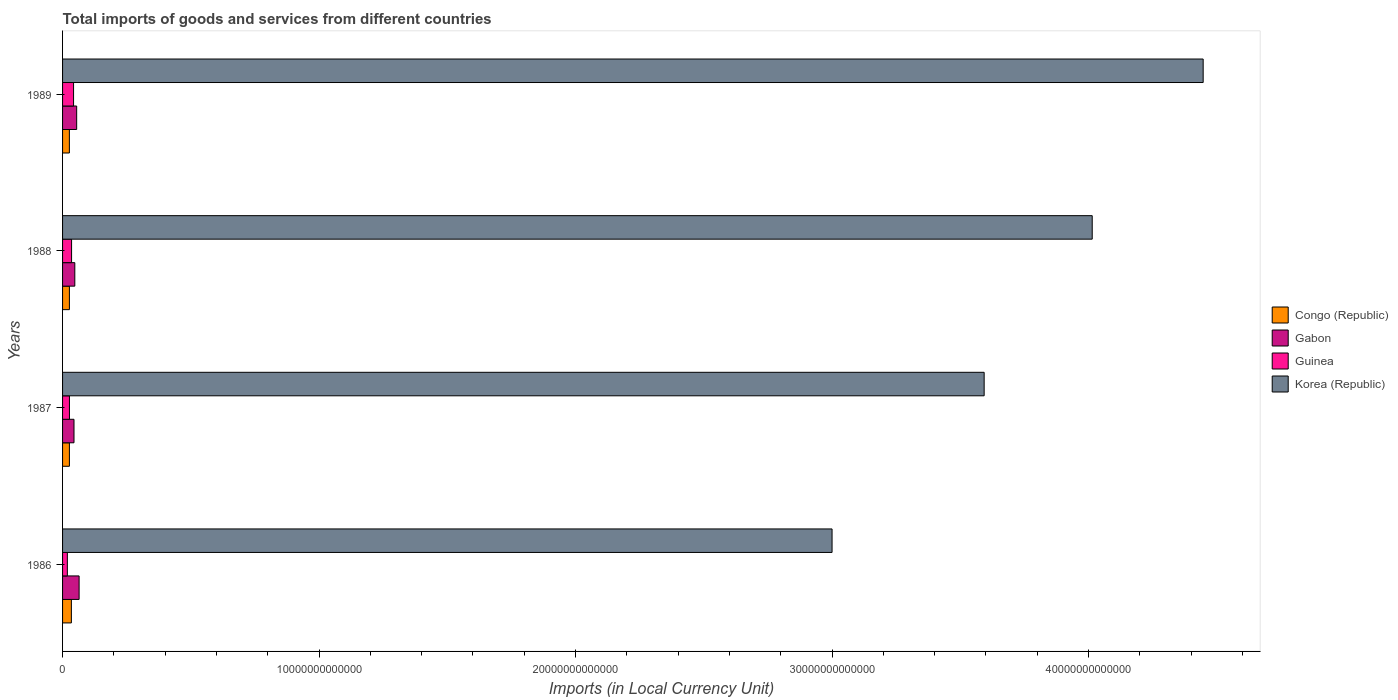How many groups of bars are there?
Ensure brevity in your answer.  4. Are the number of bars per tick equal to the number of legend labels?
Your answer should be very brief. Yes. Are the number of bars on each tick of the Y-axis equal?
Ensure brevity in your answer.  Yes. How many bars are there on the 1st tick from the top?
Provide a short and direct response. 4. How many bars are there on the 2nd tick from the bottom?
Offer a very short reply. 4. In how many cases, is the number of bars for a given year not equal to the number of legend labels?
Give a very brief answer. 0. What is the Amount of goods and services imports in Korea (Republic) in 1986?
Give a very brief answer. 3.00e+13. Across all years, what is the maximum Amount of goods and services imports in Guinea?
Your response must be concise. 4.29e+11. Across all years, what is the minimum Amount of goods and services imports in Korea (Republic)?
Make the answer very short. 3.00e+13. In which year was the Amount of goods and services imports in Korea (Republic) minimum?
Your response must be concise. 1986. What is the total Amount of goods and services imports in Korea (Republic) in the graph?
Offer a very short reply. 1.51e+14. What is the difference between the Amount of goods and services imports in Congo (Republic) in 1986 and that in 1988?
Give a very brief answer. 7.73e+1. What is the difference between the Amount of goods and services imports in Congo (Republic) in 1987 and the Amount of goods and services imports in Gabon in 1986?
Offer a terse response. -3.78e+11. What is the average Amount of goods and services imports in Korea (Republic) per year?
Your answer should be compact. 3.76e+13. In the year 1988, what is the difference between the Amount of goods and services imports in Korea (Republic) and Amount of goods and services imports in Gabon?
Your response must be concise. 3.97e+13. What is the ratio of the Amount of goods and services imports in Korea (Republic) in 1987 to that in 1988?
Give a very brief answer. 0.9. Is the Amount of goods and services imports in Congo (Republic) in 1987 less than that in 1988?
Offer a very short reply. No. Is the difference between the Amount of goods and services imports in Korea (Republic) in 1986 and 1988 greater than the difference between the Amount of goods and services imports in Gabon in 1986 and 1988?
Provide a succinct answer. No. What is the difference between the highest and the second highest Amount of goods and services imports in Korea (Republic)?
Provide a short and direct response. 4.33e+12. What is the difference between the highest and the lowest Amount of goods and services imports in Gabon?
Your response must be concise. 1.99e+11. What does the 2nd bar from the bottom in 1986 represents?
Give a very brief answer. Gabon. Is it the case that in every year, the sum of the Amount of goods and services imports in Korea (Republic) and Amount of goods and services imports in Guinea is greater than the Amount of goods and services imports in Congo (Republic)?
Offer a very short reply. Yes. How many bars are there?
Your answer should be compact. 16. How many years are there in the graph?
Keep it short and to the point. 4. What is the difference between two consecutive major ticks on the X-axis?
Keep it short and to the point. 1.00e+13. Are the values on the major ticks of X-axis written in scientific E-notation?
Your answer should be compact. No. Does the graph contain grids?
Your response must be concise. No. Where does the legend appear in the graph?
Provide a short and direct response. Center right. What is the title of the graph?
Your response must be concise. Total imports of goods and services from different countries. What is the label or title of the X-axis?
Give a very brief answer. Imports (in Local Currency Unit). What is the Imports (in Local Currency Unit) in Congo (Republic) in 1986?
Provide a succinct answer. 3.44e+11. What is the Imports (in Local Currency Unit) of Gabon in 1986?
Provide a succinct answer. 6.45e+11. What is the Imports (in Local Currency Unit) of Guinea in 1986?
Offer a terse response. 1.87e+11. What is the Imports (in Local Currency Unit) of Korea (Republic) in 1986?
Your response must be concise. 3.00e+13. What is the Imports (in Local Currency Unit) in Congo (Republic) in 1987?
Give a very brief answer. 2.67e+11. What is the Imports (in Local Currency Unit) of Gabon in 1987?
Your answer should be compact. 4.46e+11. What is the Imports (in Local Currency Unit) in Guinea in 1987?
Your response must be concise. 2.69e+11. What is the Imports (in Local Currency Unit) of Korea (Republic) in 1987?
Offer a terse response. 3.59e+13. What is the Imports (in Local Currency Unit) of Congo (Republic) in 1988?
Provide a succinct answer. 2.66e+11. What is the Imports (in Local Currency Unit) in Gabon in 1988?
Your response must be concise. 4.77e+11. What is the Imports (in Local Currency Unit) of Guinea in 1988?
Offer a very short reply. 3.51e+11. What is the Imports (in Local Currency Unit) in Korea (Republic) in 1988?
Ensure brevity in your answer.  4.01e+13. What is the Imports (in Local Currency Unit) of Congo (Republic) in 1989?
Give a very brief answer. 2.66e+11. What is the Imports (in Local Currency Unit) in Gabon in 1989?
Offer a terse response. 5.50e+11. What is the Imports (in Local Currency Unit) in Guinea in 1989?
Give a very brief answer. 4.29e+11. What is the Imports (in Local Currency Unit) of Korea (Republic) in 1989?
Offer a terse response. 4.45e+13. Across all years, what is the maximum Imports (in Local Currency Unit) of Congo (Republic)?
Provide a short and direct response. 3.44e+11. Across all years, what is the maximum Imports (in Local Currency Unit) of Gabon?
Your answer should be very brief. 6.45e+11. Across all years, what is the maximum Imports (in Local Currency Unit) of Guinea?
Make the answer very short. 4.29e+11. Across all years, what is the maximum Imports (in Local Currency Unit) in Korea (Republic)?
Ensure brevity in your answer.  4.45e+13. Across all years, what is the minimum Imports (in Local Currency Unit) in Congo (Republic)?
Ensure brevity in your answer.  2.66e+11. Across all years, what is the minimum Imports (in Local Currency Unit) of Gabon?
Offer a terse response. 4.46e+11. Across all years, what is the minimum Imports (in Local Currency Unit) in Guinea?
Ensure brevity in your answer.  1.87e+11. Across all years, what is the minimum Imports (in Local Currency Unit) of Korea (Republic)?
Ensure brevity in your answer.  3.00e+13. What is the total Imports (in Local Currency Unit) in Congo (Republic) in the graph?
Keep it short and to the point. 1.14e+12. What is the total Imports (in Local Currency Unit) of Gabon in the graph?
Make the answer very short. 2.12e+12. What is the total Imports (in Local Currency Unit) in Guinea in the graph?
Keep it short and to the point. 1.24e+12. What is the total Imports (in Local Currency Unit) of Korea (Republic) in the graph?
Offer a very short reply. 1.51e+14. What is the difference between the Imports (in Local Currency Unit) in Congo (Republic) in 1986 and that in 1987?
Give a very brief answer. 7.70e+1. What is the difference between the Imports (in Local Currency Unit) in Gabon in 1986 and that in 1987?
Make the answer very short. 1.99e+11. What is the difference between the Imports (in Local Currency Unit) of Guinea in 1986 and that in 1987?
Give a very brief answer. -8.18e+1. What is the difference between the Imports (in Local Currency Unit) of Korea (Republic) in 1986 and that in 1987?
Make the answer very short. -5.93e+12. What is the difference between the Imports (in Local Currency Unit) in Congo (Republic) in 1986 and that in 1988?
Offer a very short reply. 7.73e+1. What is the difference between the Imports (in Local Currency Unit) of Gabon in 1986 and that in 1988?
Your response must be concise. 1.68e+11. What is the difference between the Imports (in Local Currency Unit) of Guinea in 1986 and that in 1988?
Provide a succinct answer. -1.65e+11. What is the difference between the Imports (in Local Currency Unit) in Korea (Republic) in 1986 and that in 1988?
Keep it short and to the point. -1.01e+13. What is the difference between the Imports (in Local Currency Unit) of Congo (Republic) in 1986 and that in 1989?
Offer a terse response. 7.82e+1. What is the difference between the Imports (in Local Currency Unit) of Gabon in 1986 and that in 1989?
Keep it short and to the point. 9.46e+1. What is the difference between the Imports (in Local Currency Unit) in Guinea in 1986 and that in 1989?
Offer a terse response. -2.42e+11. What is the difference between the Imports (in Local Currency Unit) of Korea (Republic) in 1986 and that in 1989?
Offer a very short reply. -1.45e+13. What is the difference between the Imports (in Local Currency Unit) of Congo (Republic) in 1987 and that in 1988?
Your answer should be very brief. 3.00e+08. What is the difference between the Imports (in Local Currency Unit) in Gabon in 1987 and that in 1988?
Provide a short and direct response. -3.13e+1. What is the difference between the Imports (in Local Currency Unit) in Guinea in 1987 and that in 1988?
Offer a very short reply. -8.29e+1. What is the difference between the Imports (in Local Currency Unit) in Korea (Republic) in 1987 and that in 1988?
Give a very brief answer. -4.21e+12. What is the difference between the Imports (in Local Currency Unit) in Congo (Republic) in 1987 and that in 1989?
Your answer should be very brief. 1.20e+09. What is the difference between the Imports (in Local Currency Unit) of Gabon in 1987 and that in 1989?
Give a very brief answer. -1.04e+11. What is the difference between the Imports (in Local Currency Unit) in Guinea in 1987 and that in 1989?
Your answer should be compact. -1.60e+11. What is the difference between the Imports (in Local Currency Unit) in Korea (Republic) in 1987 and that in 1989?
Keep it short and to the point. -8.54e+12. What is the difference between the Imports (in Local Currency Unit) of Congo (Republic) in 1988 and that in 1989?
Give a very brief answer. 9.00e+08. What is the difference between the Imports (in Local Currency Unit) in Gabon in 1988 and that in 1989?
Your response must be concise. -7.29e+1. What is the difference between the Imports (in Local Currency Unit) in Guinea in 1988 and that in 1989?
Your answer should be compact. -7.71e+1. What is the difference between the Imports (in Local Currency Unit) in Korea (Republic) in 1988 and that in 1989?
Your answer should be very brief. -4.33e+12. What is the difference between the Imports (in Local Currency Unit) in Congo (Republic) in 1986 and the Imports (in Local Currency Unit) in Gabon in 1987?
Give a very brief answer. -1.02e+11. What is the difference between the Imports (in Local Currency Unit) in Congo (Republic) in 1986 and the Imports (in Local Currency Unit) in Guinea in 1987?
Provide a short and direct response. 7.52e+1. What is the difference between the Imports (in Local Currency Unit) of Congo (Republic) in 1986 and the Imports (in Local Currency Unit) of Korea (Republic) in 1987?
Provide a succinct answer. -3.56e+13. What is the difference between the Imports (in Local Currency Unit) of Gabon in 1986 and the Imports (in Local Currency Unit) of Guinea in 1987?
Make the answer very short. 3.76e+11. What is the difference between the Imports (in Local Currency Unit) in Gabon in 1986 and the Imports (in Local Currency Unit) in Korea (Republic) in 1987?
Your answer should be compact. -3.53e+13. What is the difference between the Imports (in Local Currency Unit) in Guinea in 1986 and the Imports (in Local Currency Unit) in Korea (Republic) in 1987?
Ensure brevity in your answer.  -3.57e+13. What is the difference between the Imports (in Local Currency Unit) in Congo (Republic) in 1986 and the Imports (in Local Currency Unit) in Gabon in 1988?
Keep it short and to the point. -1.34e+11. What is the difference between the Imports (in Local Currency Unit) of Congo (Republic) in 1986 and the Imports (in Local Currency Unit) of Guinea in 1988?
Provide a short and direct response. -7.78e+09. What is the difference between the Imports (in Local Currency Unit) of Congo (Republic) in 1986 and the Imports (in Local Currency Unit) of Korea (Republic) in 1988?
Provide a succinct answer. -3.98e+13. What is the difference between the Imports (in Local Currency Unit) of Gabon in 1986 and the Imports (in Local Currency Unit) of Guinea in 1988?
Your answer should be very brief. 2.93e+11. What is the difference between the Imports (in Local Currency Unit) in Gabon in 1986 and the Imports (in Local Currency Unit) in Korea (Republic) in 1988?
Your answer should be very brief. -3.95e+13. What is the difference between the Imports (in Local Currency Unit) of Guinea in 1986 and the Imports (in Local Currency Unit) of Korea (Republic) in 1988?
Make the answer very short. -4.00e+13. What is the difference between the Imports (in Local Currency Unit) in Congo (Republic) in 1986 and the Imports (in Local Currency Unit) in Gabon in 1989?
Offer a very short reply. -2.06e+11. What is the difference between the Imports (in Local Currency Unit) in Congo (Republic) in 1986 and the Imports (in Local Currency Unit) in Guinea in 1989?
Your answer should be compact. -8.49e+1. What is the difference between the Imports (in Local Currency Unit) of Congo (Republic) in 1986 and the Imports (in Local Currency Unit) of Korea (Republic) in 1989?
Your answer should be compact. -4.41e+13. What is the difference between the Imports (in Local Currency Unit) in Gabon in 1986 and the Imports (in Local Currency Unit) in Guinea in 1989?
Keep it short and to the point. 2.16e+11. What is the difference between the Imports (in Local Currency Unit) of Gabon in 1986 and the Imports (in Local Currency Unit) of Korea (Republic) in 1989?
Make the answer very short. -4.38e+13. What is the difference between the Imports (in Local Currency Unit) of Guinea in 1986 and the Imports (in Local Currency Unit) of Korea (Republic) in 1989?
Make the answer very short. -4.43e+13. What is the difference between the Imports (in Local Currency Unit) in Congo (Republic) in 1987 and the Imports (in Local Currency Unit) in Gabon in 1988?
Provide a short and direct response. -2.11e+11. What is the difference between the Imports (in Local Currency Unit) in Congo (Republic) in 1987 and the Imports (in Local Currency Unit) in Guinea in 1988?
Your answer should be very brief. -8.48e+1. What is the difference between the Imports (in Local Currency Unit) in Congo (Republic) in 1987 and the Imports (in Local Currency Unit) in Korea (Republic) in 1988?
Ensure brevity in your answer.  -3.99e+13. What is the difference between the Imports (in Local Currency Unit) in Gabon in 1987 and the Imports (in Local Currency Unit) in Guinea in 1988?
Your answer should be compact. 9.45e+1. What is the difference between the Imports (in Local Currency Unit) in Gabon in 1987 and the Imports (in Local Currency Unit) in Korea (Republic) in 1988?
Your answer should be very brief. -3.97e+13. What is the difference between the Imports (in Local Currency Unit) in Guinea in 1987 and the Imports (in Local Currency Unit) in Korea (Republic) in 1988?
Give a very brief answer. -3.99e+13. What is the difference between the Imports (in Local Currency Unit) of Congo (Republic) in 1987 and the Imports (in Local Currency Unit) of Gabon in 1989?
Offer a very short reply. -2.84e+11. What is the difference between the Imports (in Local Currency Unit) of Congo (Republic) in 1987 and the Imports (in Local Currency Unit) of Guinea in 1989?
Offer a very short reply. -1.62e+11. What is the difference between the Imports (in Local Currency Unit) in Congo (Republic) in 1987 and the Imports (in Local Currency Unit) in Korea (Republic) in 1989?
Provide a succinct answer. -4.42e+13. What is the difference between the Imports (in Local Currency Unit) of Gabon in 1987 and the Imports (in Local Currency Unit) of Guinea in 1989?
Your response must be concise. 1.74e+1. What is the difference between the Imports (in Local Currency Unit) of Gabon in 1987 and the Imports (in Local Currency Unit) of Korea (Republic) in 1989?
Your response must be concise. -4.40e+13. What is the difference between the Imports (in Local Currency Unit) in Guinea in 1987 and the Imports (in Local Currency Unit) in Korea (Republic) in 1989?
Your answer should be compact. -4.42e+13. What is the difference between the Imports (in Local Currency Unit) in Congo (Republic) in 1988 and the Imports (in Local Currency Unit) in Gabon in 1989?
Offer a very short reply. -2.84e+11. What is the difference between the Imports (in Local Currency Unit) of Congo (Republic) in 1988 and the Imports (in Local Currency Unit) of Guinea in 1989?
Keep it short and to the point. -1.62e+11. What is the difference between the Imports (in Local Currency Unit) of Congo (Republic) in 1988 and the Imports (in Local Currency Unit) of Korea (Republic) in 1989?
Make the answer very short. -4.42e+13. What is the difference between the Imports (in Local Currency Unit) of Gabon in 1988 and the Imports (in Local Currency Unit) of Guinea in 1989?
Provide a short and direct response. 4.87e+1. What is the difference between the Imports (in Local Currency Unit) of Gabon in 1988 and the Imports (in Local Currency Unit) of Korea (Republic) in 1989?
Ensure brevity in your answer.  -4.40e+13. What is the difference between the Imports (in Local Currency Unit) in Guinea in 1988 and the Imports (in Local Currency Unit) in Korea (Republic) in 1989?
Provide a succinct answer. -4.41e+13. What is the average Imports (in Local Currency Unit) of Congo (Republic) per year?
Offer a terse response. 2.86e+11. What is the average Imports (in Local Currency Unit) of Gabon per year?
Offer a terse response. 5.30e+11. What is the average Imports (in Local Currency Unit) of Guinea per year?
Your answer should be very brief. 3.09e+11. What is the average Imports (in Local Currency Unit) in Korea (Republic) per year?
Your answer should be very brief. 3.76e+13. In the year 1986, what is the difference between the Imports (in Local Currency Unit) in Congo (Republic) and Imports (in Local Currency Unit) in Gabon?
Offer a very short reply. -3.01e+11. In the year 1986, what is the difference between the Imports (in Local Currency Unit) of Congo (Republic) and Imports (in Local Currency Unit) of Guinea?
Give a very brief answer. 1.57e+11. In the year 1986, what is the difference between the Imports (in Local Currency Unit) of Congo (Republic) and Imports (in Local Currency Unit) of Korea (Republic)?
Provide a short and direct response. -2.97e+13. In the year 1986, what is the difference between the Imports (in Local Currency Unit) of Gabon and Imports (in Local Currency Unit) of Guinea?
Offer a very short reply. 4.58e+11. In the year 1986, what is the difference between the Imports (in Local Currency Unit) of Gabon and Imports (in Local Currency Unit) of Korea (Republic)?
Offer a terse response. -2.94e+13. In the year 1986, what is the difference between the Imports (in Local Currency Unit) in Guinea and Imports (in Local Currency Unit) in Korea (Republic)?
Offer a terse response. -2.98e+13. In the year 1987, what is the difference between the Imports (in Local Currency Unit) of Congo (Republic) and Imports (in Local Currency Unit) of Gabon?
Ensure brevity in your answer.  -1.79e+11. In the year 1987, what is the difference between the Imports (in Local Currency Unit) of Congo (Republic) and Imports (in Local Currency Unit) of Guinea?
Make the answer very short. -1.83e+09. In the year 1987, what is the difference between the Imports (in Local Currency Unit) in Congo (Republic) and Imports (in Local Currency Unit) in Korea (Republic)?
Offer a terse response. -3.57e+13. In the year 1987, what is the difference between the Imports (in Local Currency Unit) in Gabon and Imports (in Local Currency Unit) in Guinea?
Offer a very short reply. 1.77e+11. In the year 1987, what is the difference between the Imports (in Local Currency Unit) of Gabon and Imports (in Local Currency Unit) of Korea (Republic)?
Make the answer very short. -3.55e+13. In the year 1987, what is the difference between the Imports (in Local Currency Unit) of Guinea and Imports (in Local Currency Unit) of Korea (Republic)?
Offer a very short reply. -3.57e+13. In the year 1988, what is the difference between the Imports (in Local Currency Unit) of Congo (Republic) and Imports (in Local Currency Unit) of Gabon?
Your response must be concise. -2.11e+11. In the year 1988, what is the difference between the Imports (in Local Currency Unit) in Congo (Republic) and Imports (in Local Currency Unit) in Guinea?
Give a very brief answer. -8.51e+1. In the year 1988, what is the difference between the Imports (in Local Currency Unit) of Congo (Republic) and Imports (in Local Currency Unit) of Korea (Republic)?
Your answer should be compact. -3.99e+13. In the year 1988, what is the difference between the Imports (in Local Currency Unit) in Gabon and Imports (in Local Currency Unit) in Guinea?
Make the answer very short. 1.26e+11. In the year 1988, what is the difference between the Imports (in Local Currency Unit) of Gabon and Imports (in Local Currency Unit) of Korea (Republic)?
Provide a succinct answer. -3.97e+13. In the year 1988, what is the difference between the Imports (in Local Currency Unit) of Guinea and Imports (in Local Currency Unit) of Korea (Republic)?
Provide a succinct answer. -3.98e+13. In the year 1989, what is the difference between the Imports (in Local Currency Unit) in Congo (Republic) and Imports (in Local Currency Unit) in Gabon?
Your answer should be compact. -2.85e+11. In the year 1989, what is the difference between the Imports (in Local Currency Unit) of Congo (Republic) and Imports (in Local Currency Unit) of Guinea?
Your answer should be compact. -1.63e+11. In the year 1989, what is the difference between the Imports (in Local Currency Unit) in Congo (Republic) and Imports (in Local Currency Unit) in Korea (Republic)?
Offer a terse response. -4.42e+13. In the year 1989, what is the difference between the Imports (in Local Currency Unit) in Gabon and Imports (in Local Currency Unit) in Guinea?
Offer a very short reply. 1.22e+11. In the year 1989, what is the difference between the Imports (in Local Currency Unit) in Gabon and Imports (in Local Currency Unit) in Korea (Republic)?
Your response must be concise. -4.39e+13. In the year 1989, what is the difference between the Imports (in Local Currency Unit) of Guinea and Imports (in Local Currency Unit) of Korea (Republic)?
Give a very brief answer. -4.40e+13. What is the ratio of the Imports (in Local Currency Unit) in Congo (Republic) in 1986 to that in 1987?
Your answer should be very brief. 1.29. What is the ratio of the Imports (in Local Currency Unit) in Gabon in 1986 to that in 1987?
Provide a succinct answer. 1.45. What is the ratio of the Imports (in Local Currency Unit) of Guinea in 1986 to that in 1987?
Ensure brevity in your answer.  0.7. What is the ratio of the Imports (in Local Currency Unit) of Korea (Republic) in 1986 to that in 1987?
Keep it short and to the point. 0.83. What is the ratio of the Imports (in Local Currency Unit) of Congo (Republic) in 1986 to that in 1988?
Your answer should be compact. 1.29. What is the ratio of the Imports (in Local Currency Unit) in Gabon in 1986 to that in 1988?
Give a very brief answer. 1.35. What is the ratio of the Imports (in Local Currency Unit) of Guinea in 1986 to that in 1988?
Your answer should be compact. 0.53. What is the ratio of the Imports (in Local Currency Unit) of Korea (Republic) in 1986 to that in 1988?
Your answer should be compact. 0.75. What is the ratio of the Imports (in Local Currency Unit) in Congo (Republic) in 1986 to that in 1989?
Your answer should be very brief. 1.29. What is the ratio of the Imports (in Local Currency Unit) in Gabon in 1986 to that in 1989?
Your answer should be compact. 1.17. What is the ratio of the Imports (in Local Currency Unit) of Guinea in 1986 to that in 1989?
Your response must be concise. 0.44. What is the ratio of the Imports (in Local Currency Unit) of Korea (Republic) in 1986 to that in 1989?
Ensure brevity in your answer.  0.67. What is the ratio of the Imports (in Local Currency Unit) of Congo (Republic) in 1987 to that in 1988?
Ensure brevity in your answer.  1. What is the ratio of the Imports (in Local Currency Unit) in Gabon in 1987 to that in 1988?
Your answer should be very brief. 0.93. What is the ratio of the Imports (in Local Currency Unit) in Guinea in 1987 to that in 1988?
Offer a very short reply. 0.76. What is the ratio of the Imports (in Local Currency Unit) of Korea (Republic) in 1987 to that in 1988?
Keep it short and to the point. 0.9. What is the ratio of the Imports (in Local Currency Unit) of Congo (Republic) in 1987 to that in 1989?
Offer a terse response. 1. What is the ratio of the Imports (in Local Currency Unit) in Gabon in 1987 to that in 1989?
Offer a terse response. 0.81. What is the ratio of the Imports (in Local Currency Unit) of Guinea in 1987 to that in 1989?
Ensure brevity in your answer.  0.63. What is the ratio of the Imports (in Local Currency Unit) in Korea (Republic) in 1987 to that in 1989?
Make the answer very short. 0.81. What is the ratio of the Imports (in Local Currency Unit) in Congo (Republic) in 1988 to that in 1989?
Offer a terse response. 1. What is the ratio of the Imports (in Local Currency Unit) of Gabon in 1988 to that in 1989?
Ensure brevity in your answer.  0.87. What is the ratio of the Imports (in Local Currency Unit) of Guinea in 1988 to that in 1989?
Ensure brevity in your answer.  0.82. What is the ratio of the Imports (in Local Currency Unit) in Korea (Republic) in 1988 to that in 1989?
Give a very brief answer. 0.9. What is the difference between the highest and the second highest Imports (in Local Currency Unit) of Congo (Republic)?
Provide a succinct answer. 7.70e+1. What is the difference between the highest and the second highest Imports (in Local Currency Unit) of Gabon?
Your response must be concise. 9.46e+1. What is the difference between the highest and the second highest Imports (in Local Currency Unit) of Guinea?
Offer a terse response. 7.71e+1. What is the difference between the highest and the second highest Imports (in Local Currency Unit) in Korea (Republic)?
Make the answer very short. 4.33e+12. What is the difference between the highest and the lowest Imports (in Local Currency Unit) in Congo (Republic)?
Your answer should be very brief. 7.82e+1. What is the difference between the highest and the lowest Imports (in Local Currency Unit) of Gabon?
Offer a terse response. 1.99e+11. What is the difference between the highest and the lowest Imports (in Local Currency Unit) in Guinea?
Ensure brevity in your answer.  2.42e+11. What is the difference between the highest and the lowest Imports (in Local Currency Unit) in Korea (Republic)?
Provide a short and direct response. 1.45e+13. 